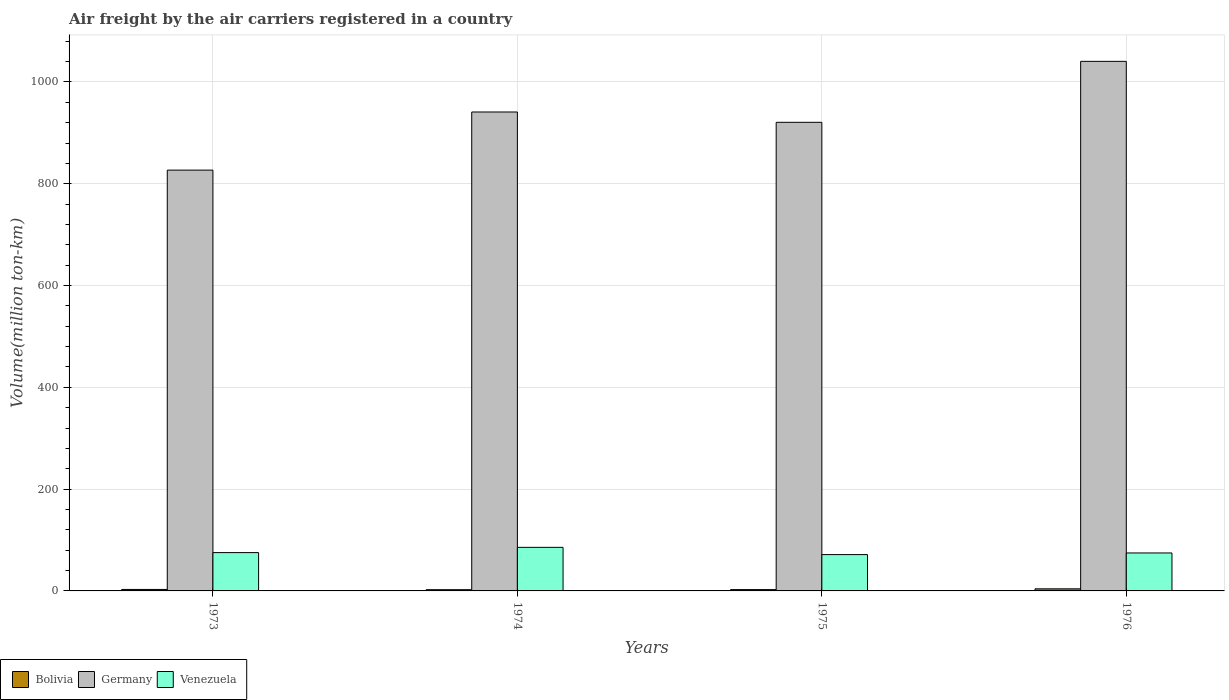Are the number of bars on each tick of the X-axis equal?
Offer a terse response. Yes. How many bars are there on the 3rd tick from the left?
Provide a short and direct response. 3. How many bars are there on the 4th tick from the right?
Keep it short and to the point. 3. What is the label of the 3rd group of bars from the left?
Give a very brief answer. 1975. In how many cases, is the number of bars for a given year not equal to the number of legend labels?
Offer a very short reply. 0. What is the volume of the air carriers in Germany in 1974?
Provide a succinct answer. 941. Across all years, what is the maximum volume of the air carriers in Bolivia?
Your answer should be compact. 4.1. Across all years, what is the minimum volume of the air carriers in Germany?
Offer a very short reply. 826.8. In which year was the volume of the air carriers in Germany maximum?
Give a very brief answer. 1976. In which year was the volume of the air carriers in Venezuela minimum?
Provide a short and direct response. 1975. What is the difference between the volume of the air carriers in Venezuela in 1974 and that in 1976?
Your answer should be compact. 11. What is the difference between the volume of the air carriers in Germany in 1976 and the volume of the air carriers in Venezuela in 1974?
Your response must be concise. 954.9. What is the average volume of the air carriers in Bolivia per year?
Offer a very short reply. 3. In the year 1976, what is the difference between the volume of the air carriers in Germany and volume of the air carriers in Bolivia?
Give a very brief answer. 1036.4. What is the ratio of the volume of the air carriers in Bolivia in 1973 to that in 1975?
Your response must be concise. 1.12. Is the volume of the air carriers in Germany in 1973 less than that in 1974?
Provide a short and direct response. Yes. What is the difference between the highest and the second highest volume of the air carriers in Venezuela?
Keep it short and to the point. 10.3. What is the difference between the highest and the lowest volume of the air carriers in Venezuela?
Provide a succinct answer. 14.2. In how many years, is the volume of the air carriers in Germany greater than the average volume of the air carriers in Germany taken over all years?
Give a very brief answer. 2. Is the sum of the volume of the air carriers in Venezuela in 1974 and 1976 greater than the maximum volume of the air carriers in Germany across all years?
Make the answer very short. No. What does the 1st bar from the right in 1975 represents?
Offer a very short reply. Venezuela. How many years are there in the graph?
Ensure brevity in your answer.  4. What is the title of the graph?
Provide a succinct answer. Air freight by the air carriers registered in a country. Does "East Asia (all income levels)" appear as one of the legend labels in the graph?
Give a very brief answer. No. What is the label or title of the X-axis?
Your response must be concise. Years. What is the label or title of the Y-axis?
Your response must be concise. Volume(million ton-km). What is the Volume(million ton-km) in Bolivia in 1973?
Keep it short and to the point. 2.9. What is the Volume(million ton-km) in Germany in 1973?
Your response must be concise. 826.8. What is the Volume(million ton-km) of Venezuela in 1973?
Ensure brevity in your answer.  75.3. What is the Volume(million ton-km) of Bolivia in 1974?
Ensure brevity in your answer.  2.4. What is the Volume(million ton-km) in Germany in 1974?
Your answer should be compact. 941. What is the Volume(million ton-km) of Venezuela in 1974?
Keep it short and to the point. 85.6. What is the Volume(million ton-km) of Bolivia in 1975?
Your answer should be compact. 2.6. What is the Volume(million ton-km) in Germany in 1975?
Your answer should be very brief. 920.7. What is the Volume(million ton-km) of Venezuela in 1975?
Offer a very short reply. 71.4. What is the Volume(million ton-km) of Bolivia in 1976?
Ensure brevity in your answer.  4.1. What is the Volume(million ton-km) in Germany in 1976?
Keep it short and to the point. 1040.5. What is the Volume(million ton-km) in Venezuela in 1976?
Give a very brief answer. 74.6. Across all years, what is the maximum Volume(million ton-km) of Bolivia?
Offer a very short reply. 4.1. Across all years, what is the maximum Volume(million ton-km) in Germany?
Offer a very short reply. 1040.5. Across all years, what is the maximum Volume(million ton-km) in Venezuela?
Provide a succinct answer. 85.6. Across all years, what is the minimum Volume(million ton-km) of Bolivia?
Provide a succinct answer. 2.4. Across all years, what is the minimum Volume(million ton-km) in Germany?
Your response must be concise. 826.8. Across all years, what is the minimum Volume(million ton-km) in Venezuela?
Keep it short and to the point. 71.4. What is the total Volume(million ton-km) of Germany in the graph?
Your response must be concise. 3729. What is the total Volume(million ton-km) of Venezuela in the graph?
Make the answer very short. 306.9. What is the difference between the Volume(million ton-km) of Bolivia in 1973 and that in 1974?
Provide a succinct answer. 0.5. What is the difference between the Volume(million ton-km) in Germany in 1973 and that in 1974?
Offer a terse response. -114.2. What is the difference between the Volume(million ton-km) of Venezuela in 1973 and that in 1974?
Give a very brief answer. -10.3. What is the difference between the Volume(million ton-km) in Germany in 1973 and that in 1975?
Give a very brief answer. -93.9. What is the difference between the Volume(million ton-km) in Germany in 1973 and that in 1976?
Offer a very short reply. -213.7. What is the difference between the Volume(million ton-km) in Germany in 1974 and that in 1975?
Give a very brief answer. 20.3. What is the difference between the Volume(million ton-km) of Venezuela in 1974 and that in 1975?
Make the answer very short. 14.2. What is the difference between the Volume(million ton-km) of Germany in 1974 and that in 1976?
Your answer should be compact. -99.5. What is the difference between the Volume(million ton-km) in Venezuela in 1974 and that in 1976?
Provide a short and direct response. 11. What is the difference between the Volume(million ton-km) of Germany in 1975 and that in 1976?
Provide a short and direct response. -119.8. What is the difference between the Volume(million ton-km) of Venezuela in 1975 and that in 1976?
Your answer should be very brief. -3.2. What is the difference between the Volume(million ton-km) in Bolivia in 1973 and the Volume(million ton-km) in Germany in 1974?
Your response must be concise. -938.1. What is the difference between the Volume(million ton-km) in Bolivia in 1973 and the Volume(million ton-km) in Venezuela in 1974?
Your answer should be very brief. -82.7. What is the difference between the Volume(million ton-km) in Germany in 1973 and the Volume(million ton-km) in Venezuela in 1974?
Ensure brevity in your answer.  741.2. What is the difference between the Volume(million ton-km) in Bolivia in 1973 and the Volume(million ton-km) in Germany in 1975?
Keep it short and to the point. -917.8. What is the difference between the Volume(million ton-km) in Bolivia in 1973 and the Volume(million ton-km) in Venezuela in 1975?
Offer a terse response. -68.5. What is the difference between the Volume(million ton-km) in Germany in 1973 and the Volume(million ton-km) in Venezuela in 1975?
Provide a short and direct response. 755.4. What is the difference between the Volume(million ton-km) in Bolivia in 1973 and the Volume(million ton-km) in Germany in 1976?
Offer a terse response. -1037.6. What is the difference between the Volume(million ton-km) in Bolivia in 1973 and the Volume(million ton-km) in Venezuela in 1976?
Your answer should be very brief. -71.7. What is the difference between the Volume(million ton-km) in Germany in 1973 and the Volume(million ton-km) in Venezuela in 1976?
Ensure brevity in your answer.  752.2. What is the difference between the Volume(million ton-km) in Bolivia in 1974 and the Volume(million ton-km) in Germany in 1975?
Give a very brief answer. -918.3. What is the difference between the Volume(million ton-km) in Bolivia in 1974 and the Volume(million ton-km) in Venezuela in 1975?
Make the answer very short. -69. What is the difference between the Volume(million ton-km) of Germany in 1974 and the Volume(million ton-km) of Venezuela in 1975?
Provide a succinct answer. 869.6. What is the difference between the Volume(million ton-km) of Bolivia in 1974 and the Volume(million ton-km) of Germany in 1976?
Offer a terse response. -1038.1. What is the difference between the Volume(million ton-km) of Bolivia in 1974 and the Volume(million ton-km) of Venezuela in 1976?
Your answer should be compact. -72.2. What is the difference between the Volume(million ton-km) in Germany in 1974 and the Volume(million ton-km) in Venezuela in 1976?
Keep it short and to the point. 866.4. What is the difference between the Volume(million ton-km) in Bolivia in 1975 and the Volume(million ton-km) in Germany in 1976?
Provide a succinct answer. -1037.9. What is the difference between the Volume(million ton-km) in Bolivia in 1975 and the Volume(million ton-km) in Venezuela in 1976?
Keep it short and to the point. -72. What is the difference between the Volume(million ton-km) in Germany in 1975 and the Volume(million ton-km) in Venezuela in 1976?
Keep it short and to the point. 846.1. What is the average Volume(million ton-km) in Bolivia per year?
Ensure brevity in your answer.  3. What is the average Volume(million ton-km) of Germany per year?
Your answer should be very brief. 932.25. What is the average Volume(million ton-km) of Venezuela per year?
Make the answer very short. 76.72. In the year 1973, what is the difference between the Volume(million ton-km) in Bolivia and Volume(million ton-km) in Germany?
Your response must be concise. -823.9. In the year 1973, what is the difference between the Volume(million ton-km) in Bolivia and Volume(million ton-km) in Venezuela?
Your response must be concise. -72.4. In the year 1973, what is the difference between the Volume(million ton-km) of Germany and Volume(million ton-km) of Venezuela?
Provide a short and direct response. 751.5. In the year 1974, what is the difference between the Volume(million ton-km) of Bolivia and Volume(million ton-km) of Germany?
Your answer should be compact. -938.6. In the year 1974, what is the difference between the Volume(million ton-km) in Bolivia and Volume(million ton-km) in Venezuela?
Ensure brevity in your answer.  -83.2. In the year 1974, what is the difference between the Volume(million ton-km) of Germany and Volume(million ton-km) of Venezuela?
Provide a succinct answer. 855.4. In the year 1975, what is the difference between the Volume(million ton-km) of Bolivia and Volume(million ton-km) of Germany?
Give a very brief answer. -918.1. In the year 1975, what is the difference between the Volume(million ton-km) in Bolivia and Volume(million ton-km) in Venezuela?
Offer a very short reply. -68.8. In the year 1975, what is the difference between the Volume(million ton-km) in Germany and Volume(million ton-km) in Venezuela?
Keep it short and to the point. 849.3. In the year 1976, what is the difference between the Volume(million ton-km) in Bolivia and Volume(million ton-km) in Germany?
Offer a terse response. -1036.4. In the year 1976, what is the difference between the Volume(million ton-km) of Bolivia and Volume(million ton-km) of Venezuela?
Ensure brevity in your answer.  -70.5. In the year 1976, what is the difference between the Volume(million ton-km) of Germany and Volume(million ton-km) of Venezuela?
Ensure brevity in your answer.  965.9. What is the ratio of the Volume(million ton-km) of Bolivia in 1973 to that in 1974?
Your answer should be very brief. 1.21. What is the ratio of the Volume(million ton-km) in Germany in 1973 to that in 1974?
Offer a very short reply. 0.88. What is the ratio of the Volume(million ton-km) of Venezuela in 1973 to that in 1974?
Offer a very short reply. 0.88. What is the ratio of the Volume(million ton-km) of Bolivia in 1973 to that in 1975?
Your answer should be compact. 1.12. What is the ratio of the Volume(million ton-km) in Germany in 1973 to that in 1975?
Give a very brief answer. 0.9. What is the ratio of the Volume(million ton-km) in Venezuela in 1973 to that in 1975?
Offer a very short reply. 1.05. What is the ratio of the Volume(million ton-km) in Bolivia in 1973 to that in 1976?
Offer a very short reply. 0.71. What is the ratio of the Volume(million ton-km) of Germany in 1973 to that in 1976?
Your answer should be very brief. 0.79. What is the ratio of the Volume(million ton-km) of Venezuela in 1973 to that in 1976?
Offer a terse response. 1.01. What is the ratio of the Volume(million ton-km) in Germany in 1974 to that in 1975?
Provide a succinct answer. 1.02. What is the ratio of the Volume(million ton-km) of Venezuela in 1974 to that in 1975?
Offer a very short reply. 1.2. What is the ratio of the Volume(million ton-km) of Bolivia in 1974 to that in 1976?
Your answer should be very brief. 0.59. What is the ratio of the Volume(million ton-km) in Germany in 1974 to that in 1976?
Offer a very short reply. 0.9. What is the ratio of the Volume(million ton-km) in Venezuela in 1974 to that in 1976?
Ensure brevity in your answer.  1.15. What is the ratio of the Volume(million ton-km) in Bolivia in 1975 to that in 1976?
Offer a very short reply. 0.63. What is the ratio of the Volume(million ton-km) in Germany in 1975 to that in 1976?
Give a very brief answer. 0.88. What is the ratio of the Volume(million ton-km) in Venezuela in 1975 to that in 1976?
Give a very brief answer. 0.96. What is the difference between the highest and the second highest Volume(million ton-km) in Germany?
Ensure brevity in your answer.  99.5. What is the difference between the highest and the lowest Volume(million ton-km) in Germany?
Provide a succinct answer. 213.7. 